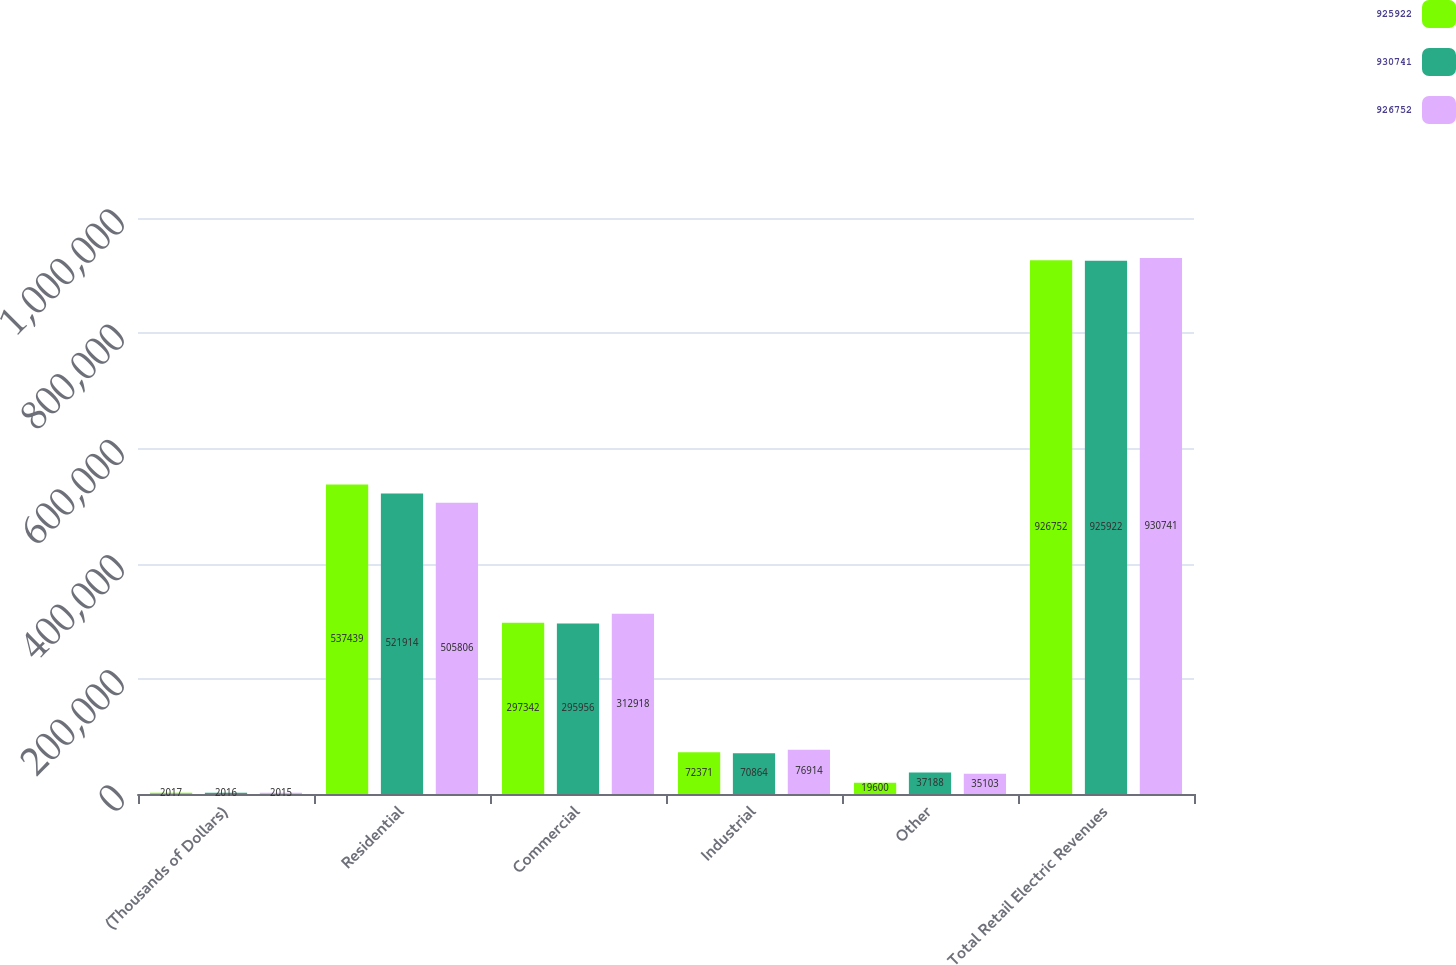<chart> <loc_0><loc_0><loc_500><loc_500><stacked_bar_chart><ecel><fcel>(Thousands of Dollars)<fcel>Residential<fcel>Commercial<fcel>Industrial<fcel>Other<fcel>Total Retail Electric Revenues<nl><fcel>925922<fcel>2017<fcel>537439<fcel>297342<fcel>72371<fcel>19600<fcel>926752<nl><fcel>930741<fcel>2016<fcel>521914<fcel>295956<fcel>70864<fcel>37188<fcel>925922<nl><fcel>926752<fcel>2015<fcel>505806<fcel>312918<fcel>76914<fcel>35103<fcel>930741<nl></chart> 